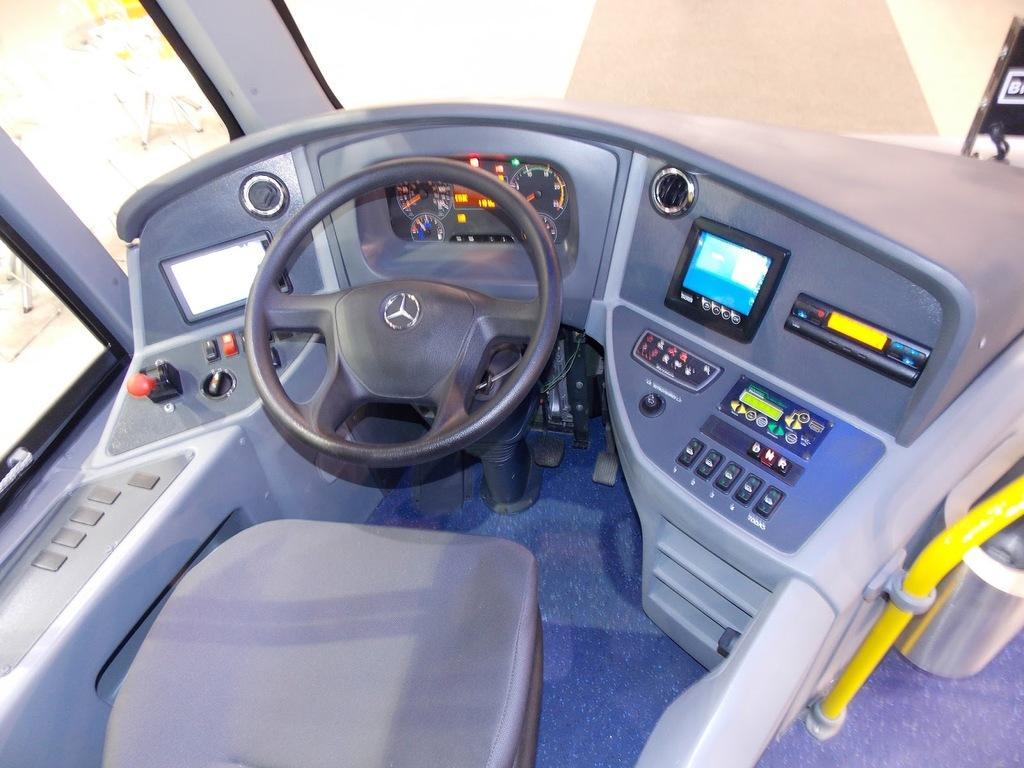What is the primary object in the image? There is a seat in the image. What feature is associated with the seat? There is a steering wheel in the image. What else can be seen in front of the seat? There are other objects in front of the seat. What type of prose is being written on the seat in the image? There is no prose or writing present on the seat in the image. How much glue is needed to attach the objects to the seat in the image? There is no indication in the image that any objects are being attached to the seat with glue. 